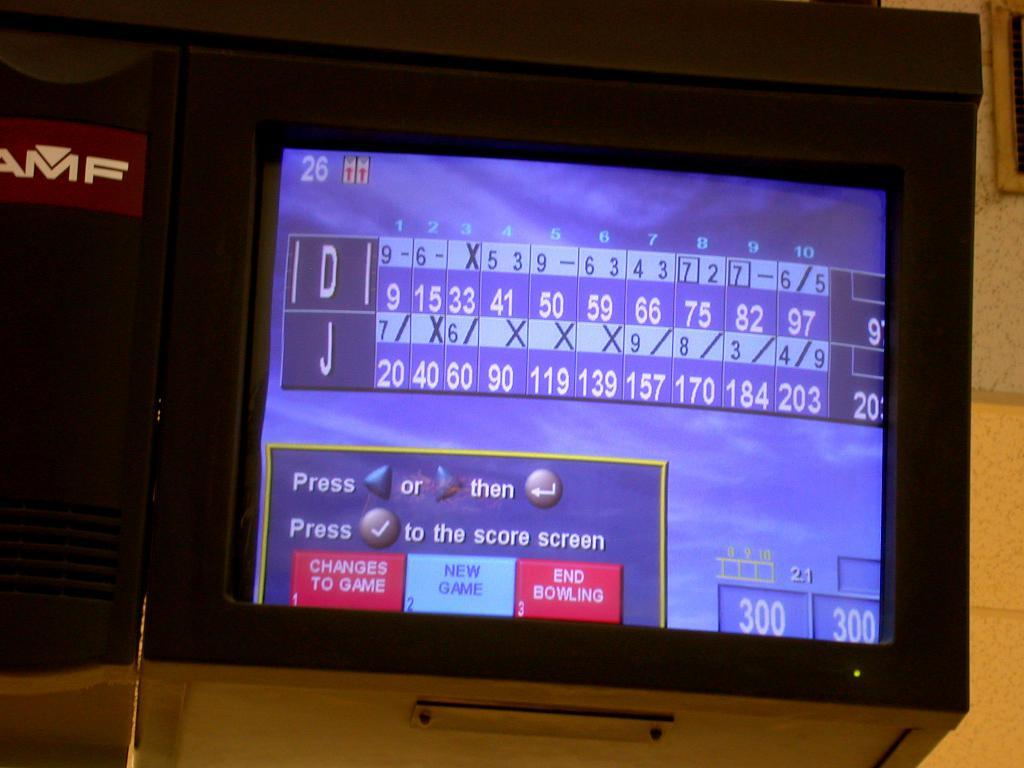<image>
Write a terse but informative summary of the picture. An AMF bowling alley screen showing a scoreboard between D and J 